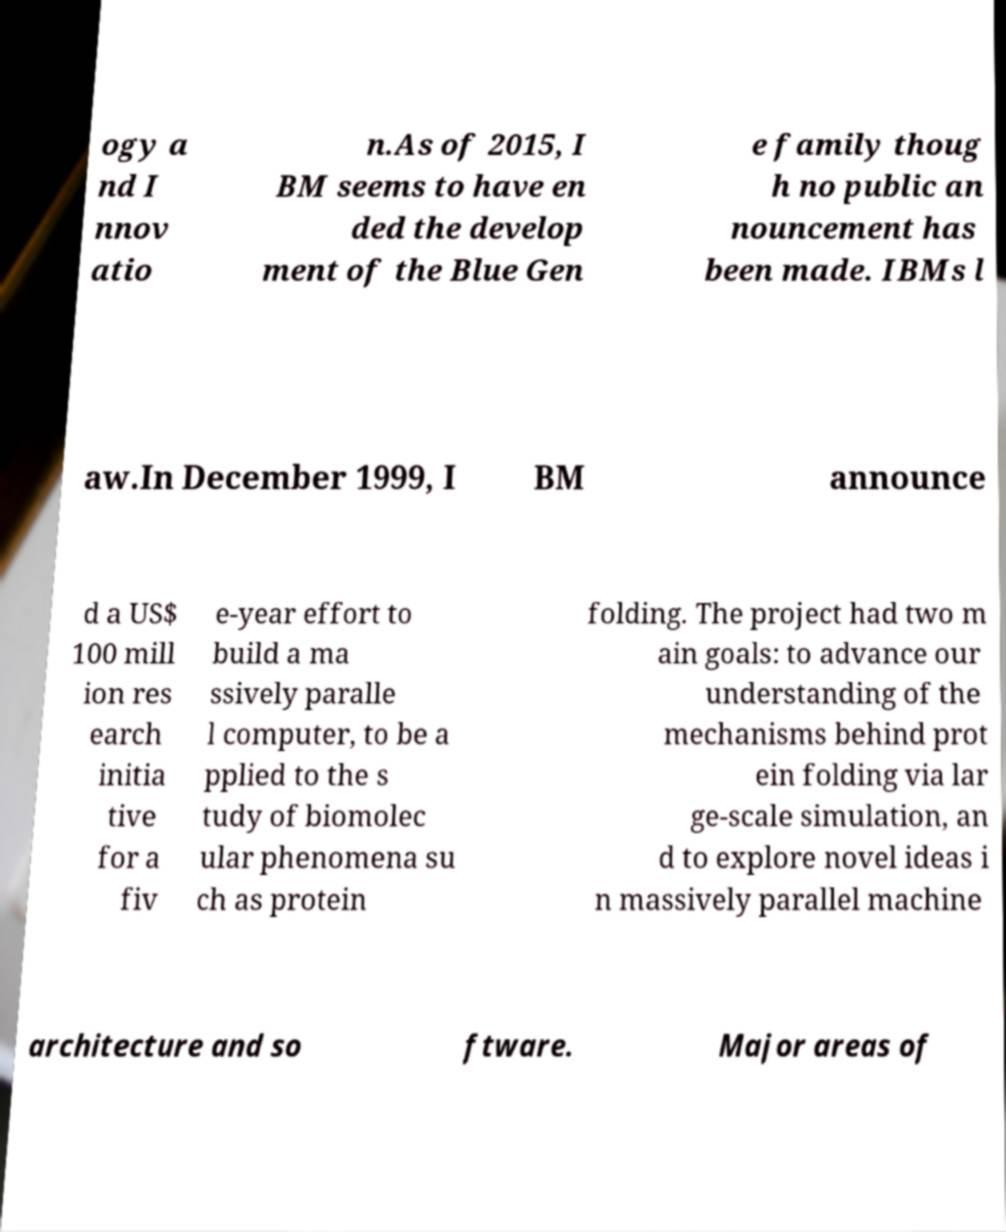Could you extract and type out the text from this image? ogy a nd I nnov atio n.As of 2015, I BM seems to have en ded the develop ment of the Blue Gen e family thoug h no public an nouncement has been made. IBMs l aw.In December 1999, I BM announce d a US$ 100 mill ion res earch initia tive for a fiv e-year effort to build a ma ssively paralle l computer, to be a pplied to the s tudy of biomolec ular phenomena su ch as protein folding. The project had two m ain goals: to advance our understanding of the mechanisms behind prot ein folding via lar ge-scale simulation, an d to explore novel ideas i n massively parallel machine architecture and so ftware. Major areas of 